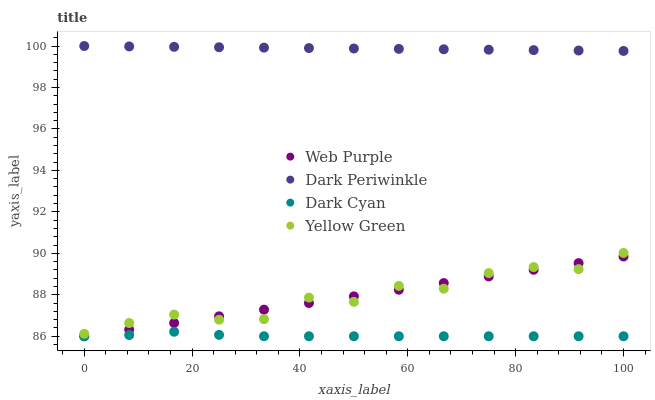Does Dark Cyan have the minimum area under the curve?
Answer yes or no. Yes. Does Dark Periwinkle have the maximum area under the curve?
Answer yes or no. Yes. Does Web Purple have the minimum area under the curve?
Answer yes or no. No. Does Web Purple have the maximum area under the curve?
Answer yes or no. No. Is Web Purple the smoothest?
Answer yes or no. Yes. Is Yellow Green the roughest?
Answer yes or no. Yes. Is Dark Periwinkle the smoothest?
Answer yes or no. No. Is Dark Periwinkle the roughest?
Answer yes or no. No. Does Dark Cyan have the lowest value?
Answer yes or no. Yes. Does Dark Periwinkle have the lowest value?
Answer yes or no. No. Does Dark Periwinkle have the highest value?
Answer yes or no. Yes. Does Web Purple have the highest value?
Answer yes or no. No. Is Yellow Green less than Dark Periwinkle?
Answer yes or no. Yes. Is Dark Periwinkle greater than Web Purple?
Answer yes or no. Yes. Does Web Purple intersect Yellow Green?
Answer yes or no. Yes. Is Web Purple less than Yellow Green?
Answer yes or no. No. Is Web Purple greater than Yellow Green?
Answer yes or no. No. Does Yellow Green intersect Dark Periwinkle?
Answer yes or no. No. 